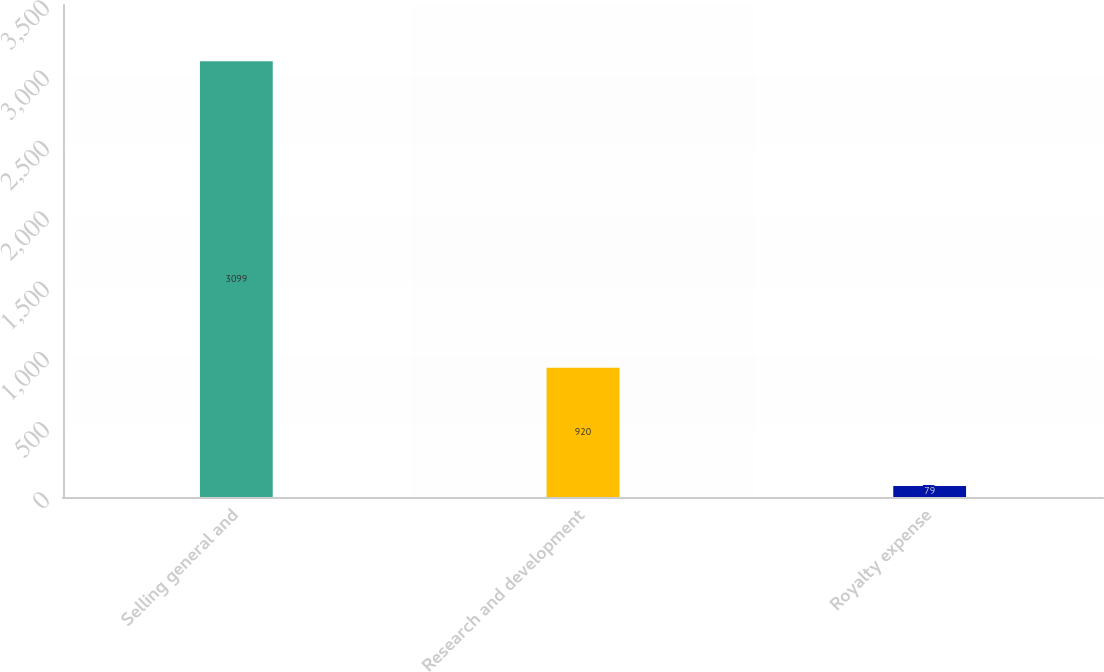Convert chart. <chart><loc_0><loc_0><loc_500><loc_500><bar_chart><fcel>Selling general and<fcel>Research and development<fcel>Royalty expense<nl><fcel>3099<fcel>920<fcel>79<nl></chart> 